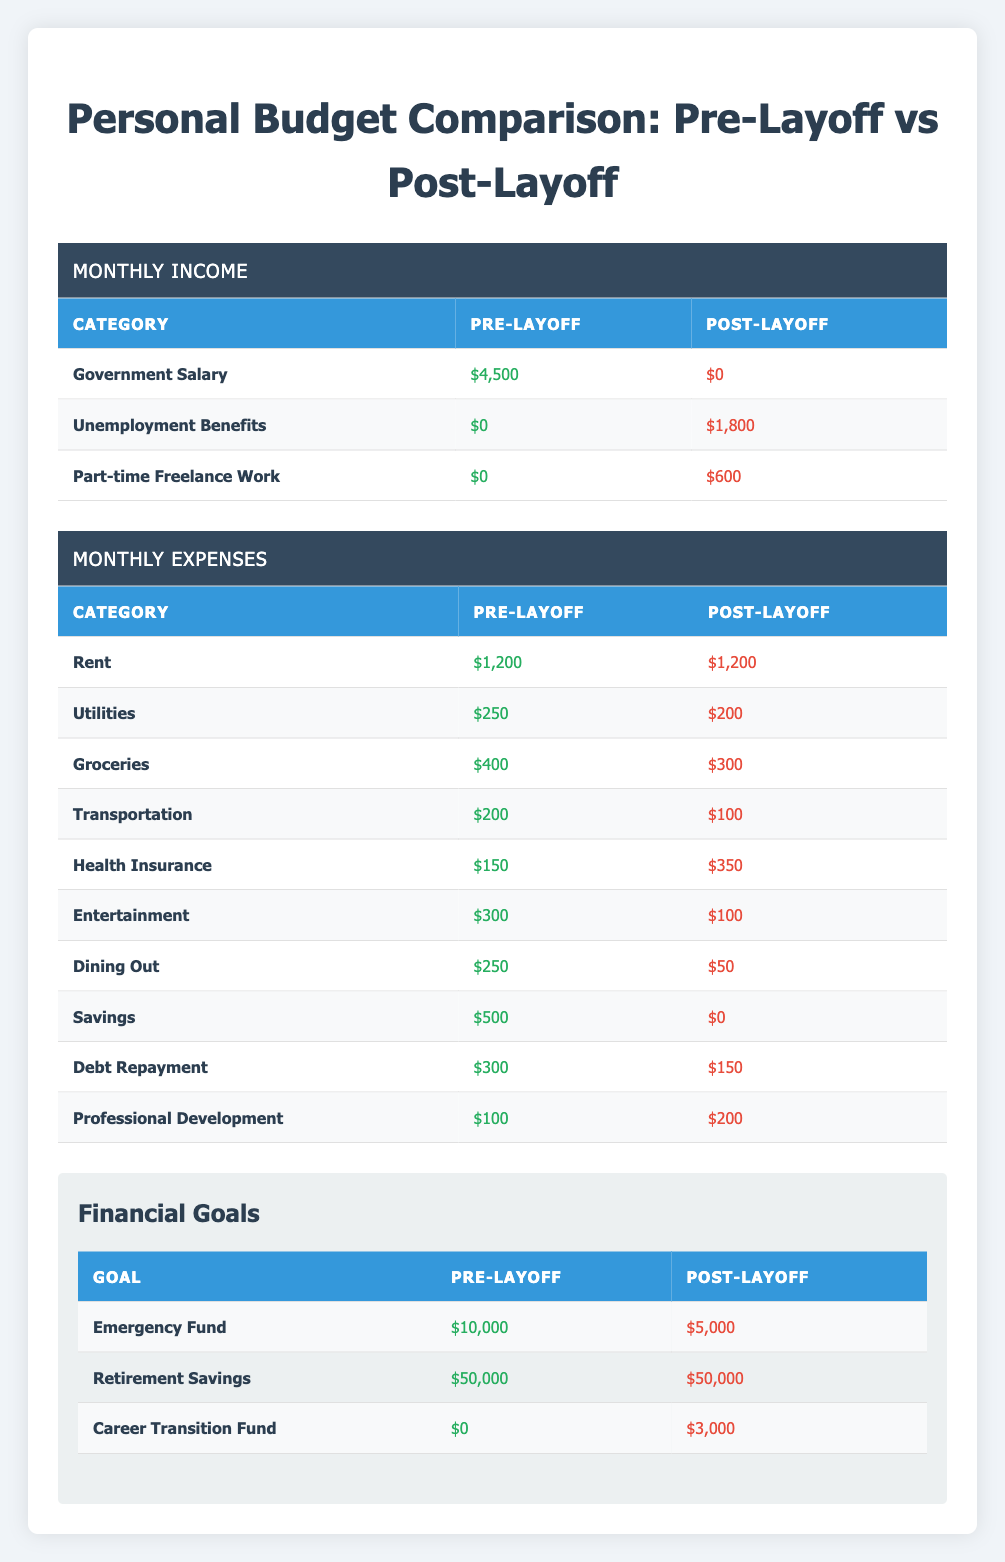What was the total monthly income pre-layoff? The pre-layoff income includes government salary ($4500), unemployment benefits ($0), and part-time freelance work ($0). Therefore, total pre-layoff income = 4500 + 0 + 0 = 4500.
Answer: 4500 What are the total monthly expenses post-layoff? The post-layoff expenses are rent ($1200), utilities ($200), groceries ($300), transportation ($100), health insurance ($350), entertainment ($100), dining out ($50), savings ($0), debt repayment ($150), and professional development ($200). Total post-layoff expenses = 1200 + 200 + 300 + 100 + 350 + 100 + 50 + 0 + 150 + 200 = 2650.
Answer: 2650 Did the rent expense remain the same before and after the layoff? The rent expense is $1200 both before and after the layoff, which means it did not change.
Answer: Yes What is the difference in grocery expenses before and after the layoff? The grocery expense pre-layoff was $400, and post-layoff it is $300. The difference = 400 - 300 = 100.
Answer: 100 How much did the health insurance cost increase after the layoff? The health insurance cost pre-layoff was $150, and post-layoff it is $350. The increase = 350 - 150 = 200.
Answer: 200 What percentage of the pre-layoff income was allocated to savings? Pre-layoff savings was $500, and total income was $4500. The percentage = (500 / 4500) * 100 = 11.11%.
Answer: 11.11% How much did the total monthly income change from pre-layoff to post-layoff? Pre-layoff income was $4500 and post-layoff income is $2400 ($1800 in unemployment benefits + $600 in freelance work). The change = 2400 - 4500 = -2100.
Answer: -2100 Is the post-layoff value for the emergency fund greater than the pre-layoff value? The pre-layoff emergency fund was $10,000, while the post-layoff value is $5,000. Since 5,000 is less than 10,000, the statement is false.
Answer: No How much are the total funds allocated for professional development before and after the layoff? The pre-layoff professional development fund is $100 and post-layoff is $200. The total allocation = 100 + 200 = 300.
Answer: 300 What is the relationship between the savings and the career transition fund post-layoff? Post-layoff savings is $0, while the career transition fund is $3000. This indicates that the savings have been eliminated, but funds have been allocated towards transitioning careers.
Answer: Savings decreased while career fund increased 